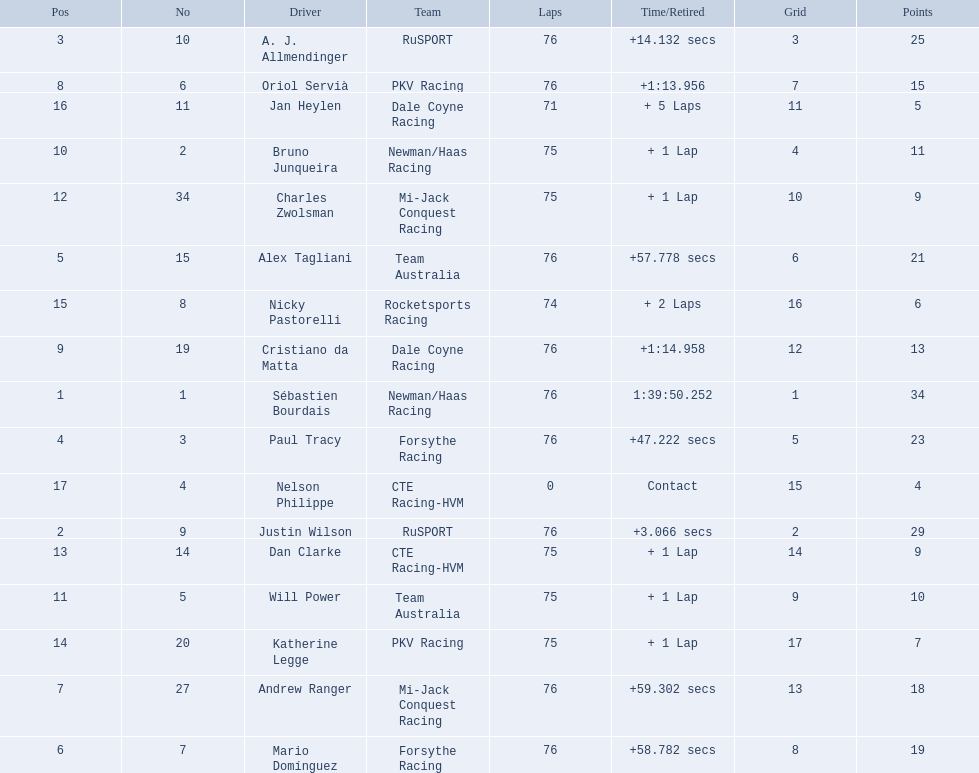Who drove during the 2006 tecate grand prix of monterrey? Sébastien Bourdais, Justin Wilson, A. J. Allmendinger, Paul Tracy, Alex Tagliani, Mario Domínguez, Andrew Ranger, Oriol Servià, Cristiano da Matta, Bruno Junqueira, Will Power, Charles Zwolsman, Dan Clarke, Katherine Legge, Nicky Pastorelli, Jan Heylen, Nelson Philippe. And what were their finishing positions? 1, 2, 3, 4, 5, 6, 7, 8, 9, 10, 11, 12, 13, 14, 15, 16, 17. Who did alex tagliani finish directly behind of? Paul Tracy. 